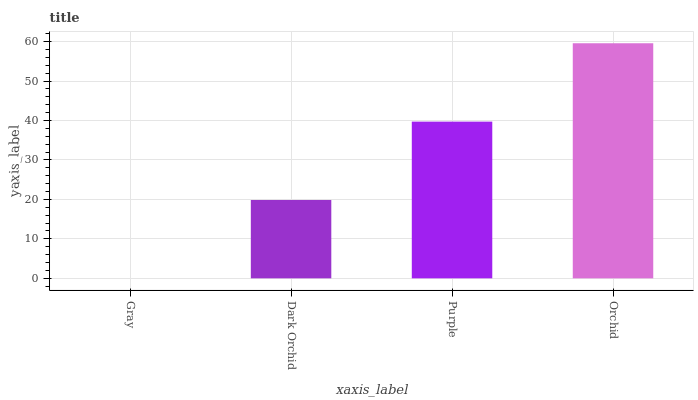Is Gray the minimum?
Answer yes or no. Yes. Is Orchid the maximum?
Answer yes or no. Yes. Is Dark Orchid the minimum?
Answer yes or no. No. Is Dark Orchid the maximum?
Answer yes or no. No. Is Dark Orchid greater than Gray?
Answer yes or no. Yes. Is Gray less than Dark Orchid?
Answer yes or no. Yes. Is Gray greater than Dark Orchid?
Answer yes or no. No. Is Dark Orchid less than Gray?
Answer yes or no. No. Is Purple the high median?
Answer yes or no. Yes. Is Dark Orchid the low median?
Answer yes or no. Yes. Is Gray the high median?
Answer yes or no. No. Is Gray the low median?
Answer yes or no. No. 